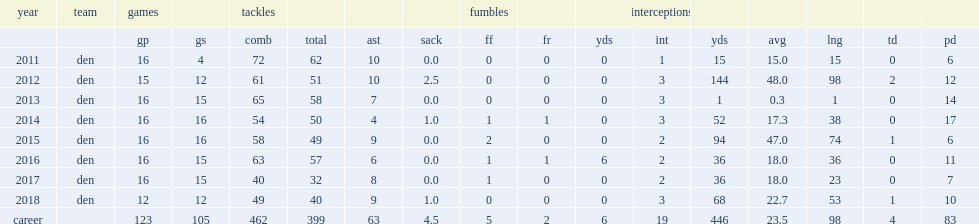In 2012, how many interception yards did chris harris jr. have? 144.0. 